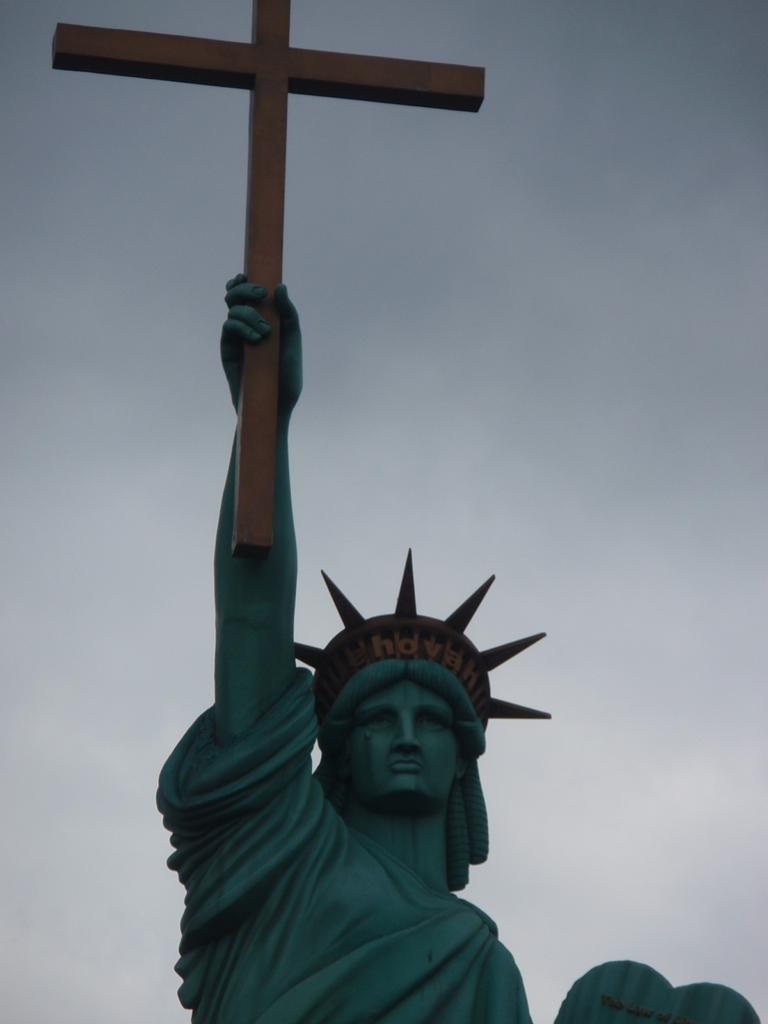What is the main subject of the image? There is a statue in the image. What is the statue holding in its hands? The statue is holding a holy cross in its hands. How many minutes does the statue take to help people in the park? The image does not depict the statue helping people or a park, so it is not possible to determine how many minutes it might take for such an event to occur. 